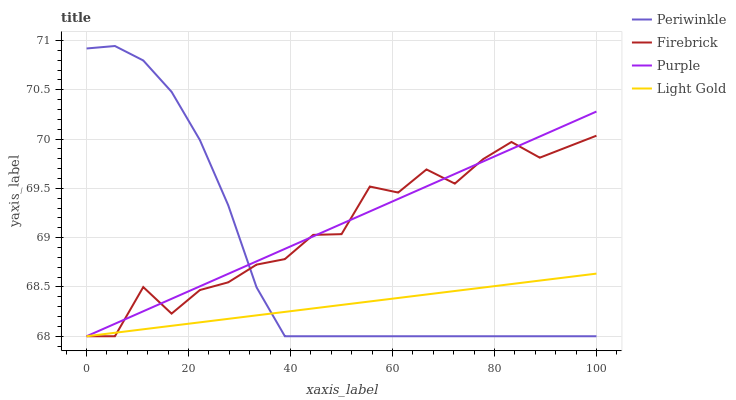Does Light Gold have the minimum area under the curve?
Answer yes or no. Yes. Does Purple have the maximum area under the curve?
Answer yes or no. Yes. Does Firebrick have the minimum area under the curve?
Answer yes or no. No. Does Firebrick have the maximum area under the curve?
Answer yes or no. No. Is Light Gold the smoothest?
Answer yes or no. Yes. Is Firebrick the roughest?
Answer yes or no. Yes. Is Firebrick the smoothest?
Answer yes or no. No. Is Light Gold the roughest?
Answer yes or no. No. Does Periwinkle have the highest value?
Answer yes or no. Yes. Does Firebrick have the highest value?
Answer yes or no. No. Does Purple intersect Light Gold?
Answer yes or no. Yes. Is Purple less than Light Gold?
Answer yes or no. No. Is Purple greater than Light Gold?
Answer yes or no. No. 